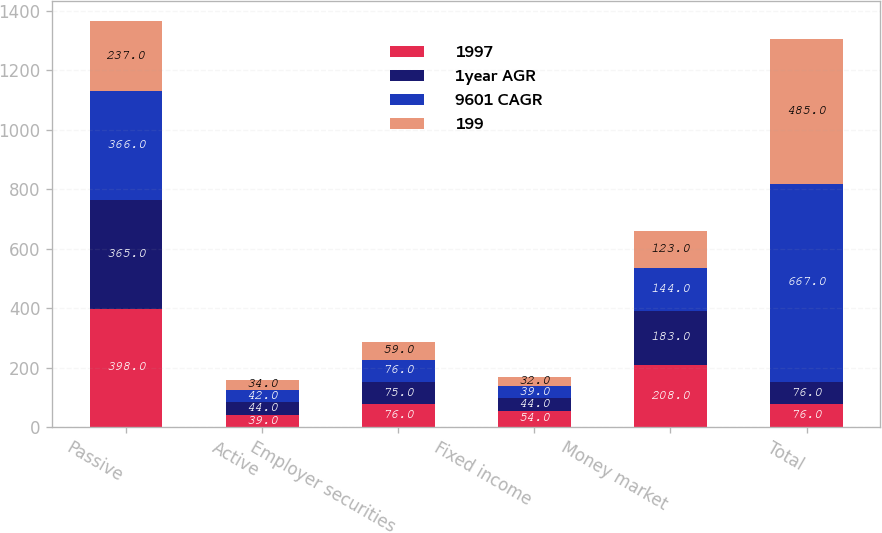<chart> <loc_0><loc_0><loc_500><loc_500><stacked_bar_chart><ecel><fcel>Passive<fcel>Active<fcel>Employer securities<fcel>Fixed income<fcel>Money market<fcel>Total<nl><fcel>1997<fcel>398<fcel>39<fcel>76<fcel>54<fcel>208<fcel>76<nl><fcel>1year AGR<fcel>365<fcel>44<fcel>75<fcel>44<fcel>183<fcel>76<nl><fcel>9601 CAGR<fcel>366<fcel>42<fcel>76<fcel>39<fcel>144<fcel>667<nl><fcel>199<fcel>237<fcel>34<fcel>59<fcel>32<fcel>123<fcel>485<nl></chart> 